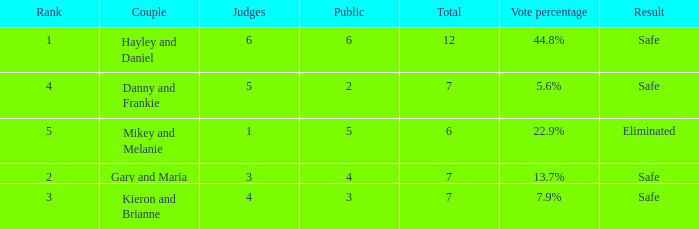How many judges were there for the eliminated couple?  1.0. 